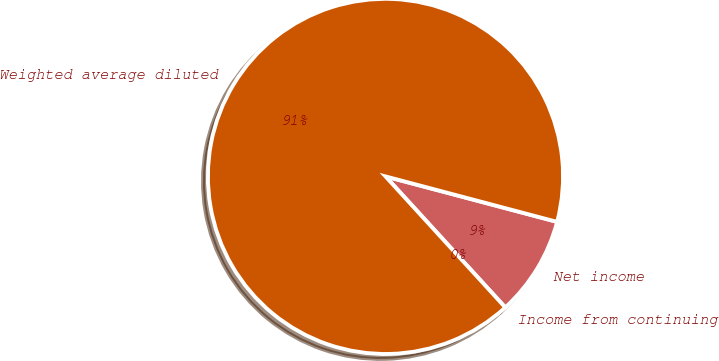<chart> <loc_0><loc_0><loc_500><loc_500><pie_chart><fcel>Income from continuing<fcel>Net income<fcel>Weighted average diluted<nl><fcel>0.0%<fcel>9.09%<fcel>90.91%<nl></chart> 